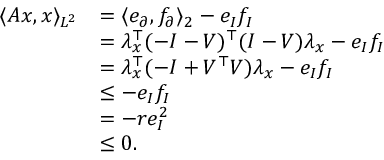<formula> <loc_0><loc_0><loc_500><loc_500>\begin{array} { r l } { \langle A x , x \rangle _ { L ^ { 2 } } } & { = \langle e _ { \partial } , f _ { \partial } \rangle _ { 2 } - e _ { I } f _ { I } } \\ & { = \lambda _ { x } ^ { \top } ( - I - V ) ^ { \top } ( I - V ) \lambda _ { x } - e _ { I } f _ { I } } \\ & { = \lambda _ { x } ^ { \top } ( - I + V ^ { \top } V ) \lambda _ { x } - e _ { I } f _ { I } } \\ & { \leq - e _ { I } f _ { I } } \\ & { = - r e _ { I } ^ { 2 } } \\ & { \leq 0 . } \end{array}</formula> 